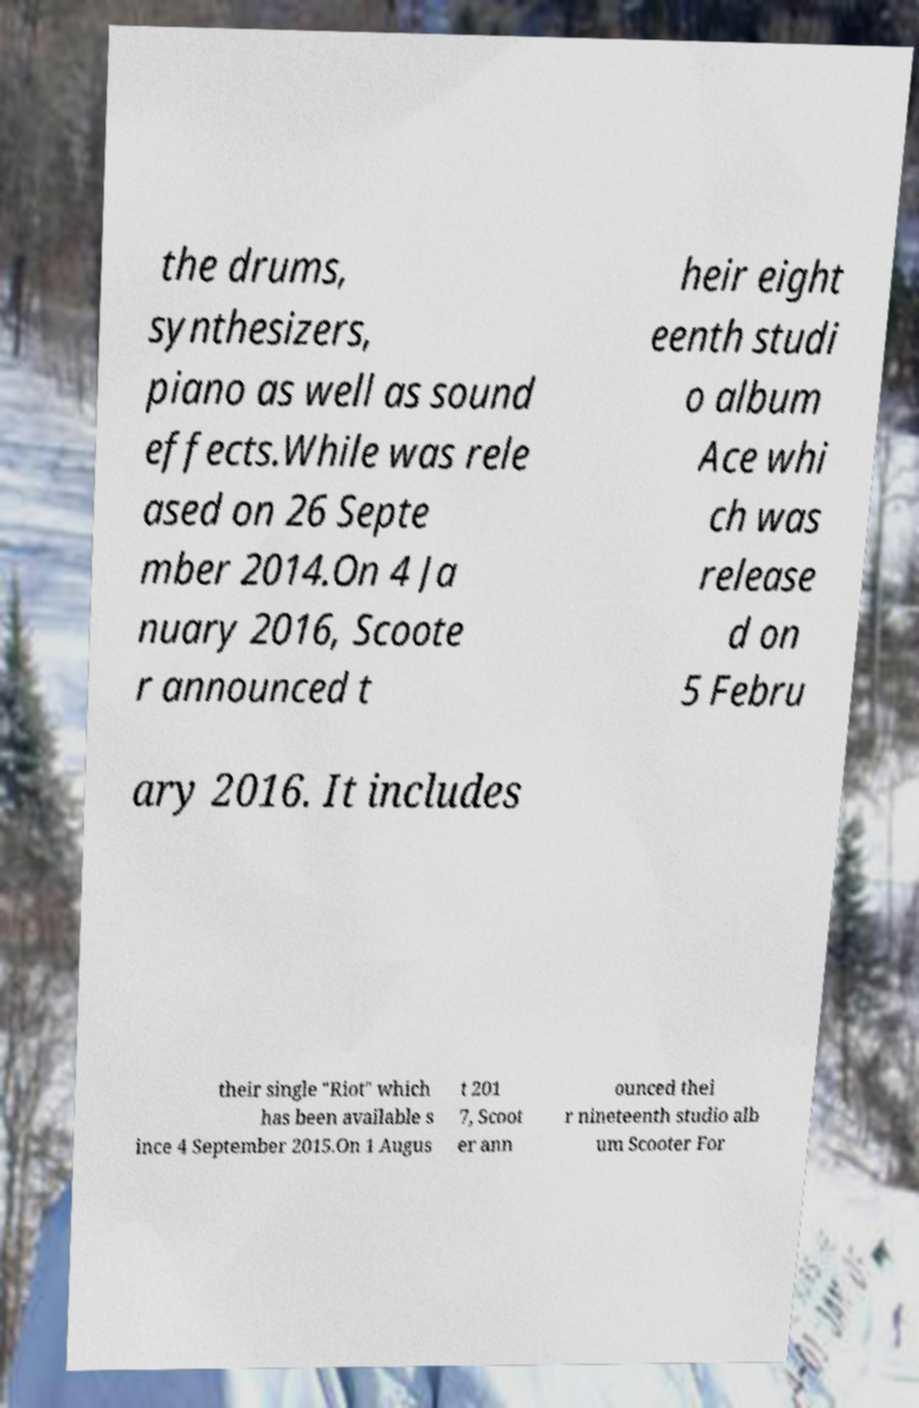Please read and relay the text visible in this image. What does it say? the drums, synthesizers, piano as well as sound effects.While was rele ased on 26 Septe mber 2014.On 4 Ja nuary 2016, Scoote r announced t heir eight eenth studi o album Ace whi ch was release d on 5 Febru ary 2016. It includes their single "Riot" which has been available s ince 4 September 2015.On 1 Augus t 201 7, Scoot er ann ounced thei r nineteenth studio alb um Scooter For 